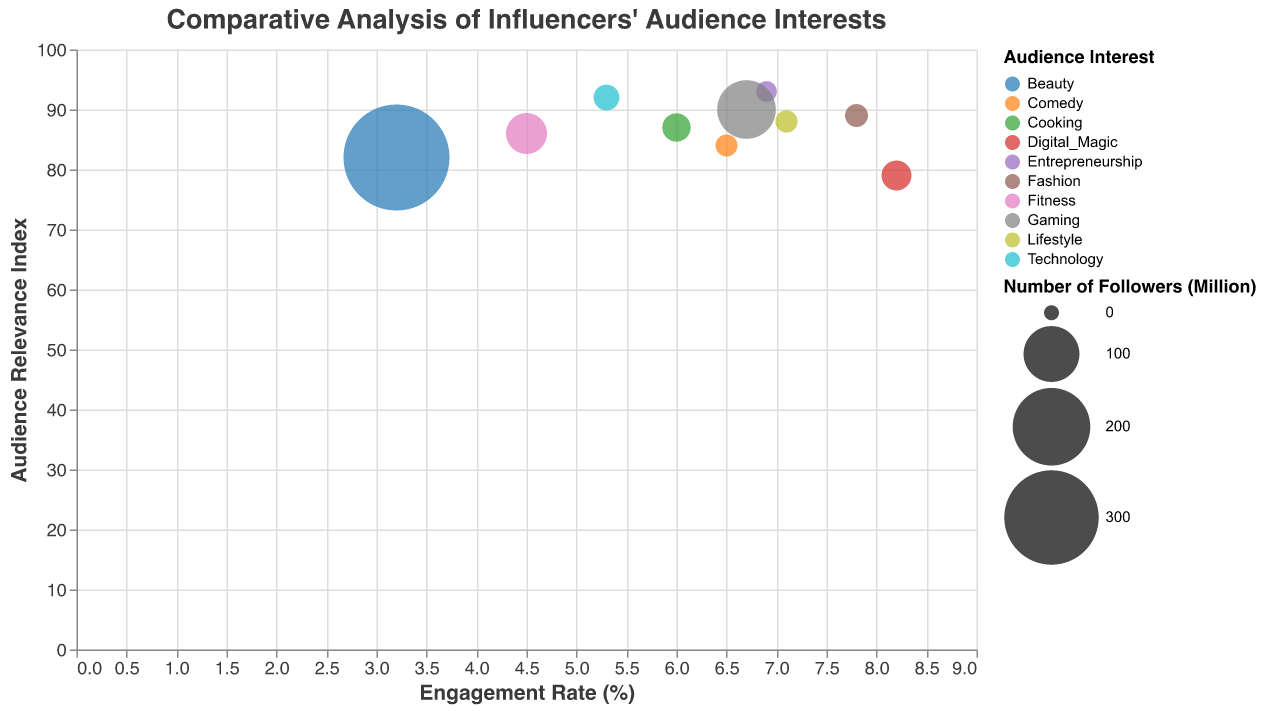What is the title of the chart? The title of the chart is displayed at the top of the figure.
Answer: "Comparative Analysis of Influencers' Audience Interests" How many influencers are shown in the chart? Count the number of unique data points in the chart, each representing an influencer.
Answer: 10 Which influencer has the highest engagement rate? Locate the data point farthest to the right (highest x-axis value) on the chart.
Answer: Zach King Which audience interest has the most followers represented by the biggest bubble? Identify the largest bubble visually and reference its associated audience interest.
Answer: Beauty (Kylie Jenner) Whose audience has the highest relevance index score? Look for the data point positioned highest on the y-axis (Audience Relevance Index).
Answer: GaryVee Compare the engagement rates of Emma Chamberlain and David Dobrik. Who has a higher rate? Locate the data points for both Emma Chamberlain and David Dobrik and compare their positions on the x-axis (Engagement Rate).
Answer: Emma Chamberlain What are the Audience Relevance Index and Engagement Rate for Gordon Ramsay? Find Gordon Ramsay's data point and read off the y-axis (Audience Relevance Index) and x-axis (Engagement Rate).
Answer: Audience Relevance Index: 87, Engagement Rate: 6.0% What is the combined number of followers for Chris Hemsworth and Gordon Ramsay? Find the bubbles representing Chris Hemsworth and Gordon Ramsay, sum their follower counts.
Answer: 50.1 + 20.1 = 70.2 million Who has a higher Audience Relevance Index, Marques Brownlee or PewDiePie? Compare the y-axis values for Marques Brownlee and PewDiePie's data points.
Answer: PewDiePie What's the relationship between engagement rate and audience relevance index for influencers with over 100 million followers? Identify the data points for influencers with over 100 million followers (Kylie Jenner, PewDiePie) and analyze their positions on the x and y axes.
Answer: High engagement with high relevance (PewDiePie); low engagement with moderate relevance (Kylie Jenner) 